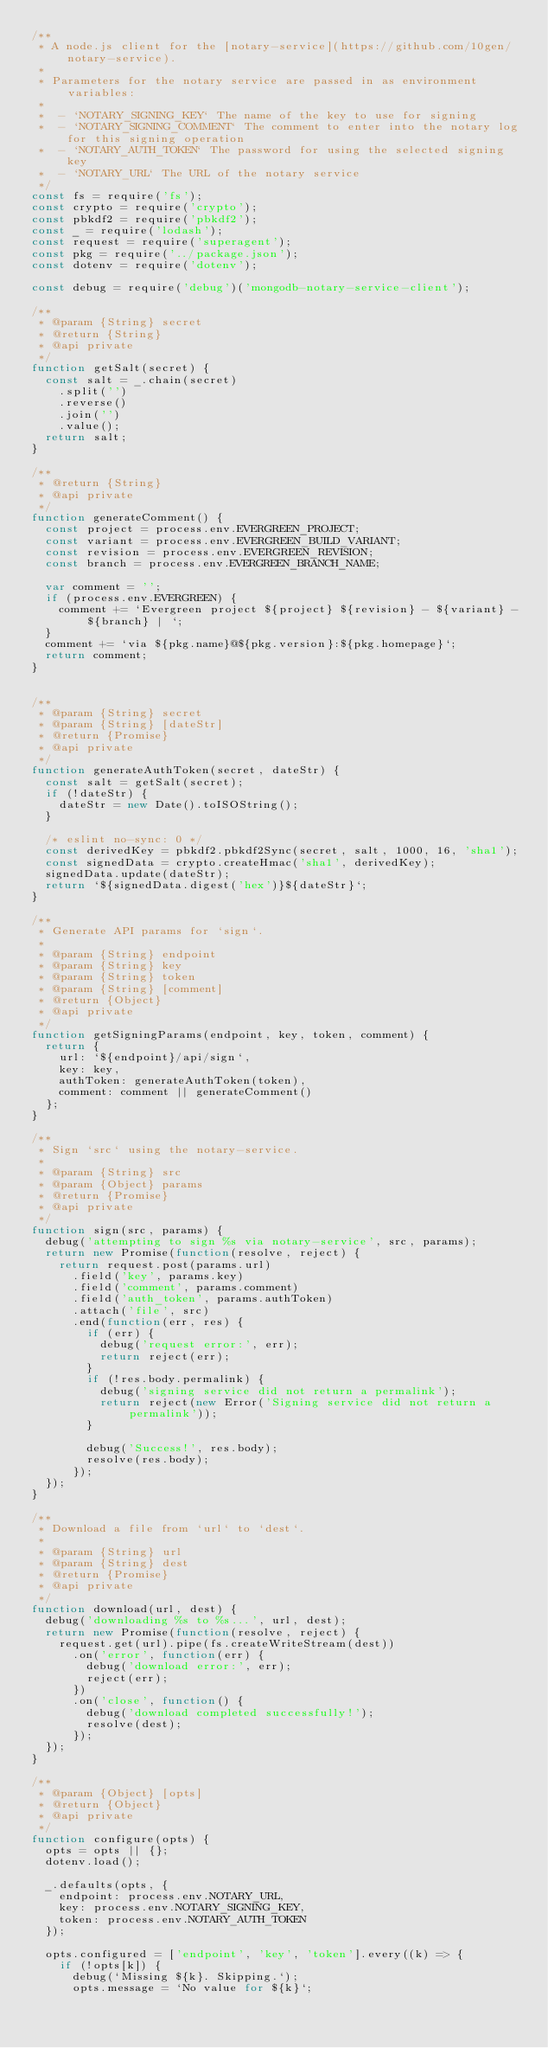Convert code to text. <code><loc_0><loc_0><loc_500><loc_500><_JavaScript_>/**
 * A node.js client for the [notary-service](https://github.com/10gen/notary-service).
 *
 * Parameters for the notary service are passed in as environment variables:
 *
 *  - `NOTARY_SIGNING_KEY` The name of the key to use for signing
 *  - `NOTARY_SIGNING_COMMENT` The comment to enter into the notary log for this signing operation
 *  - `NOTARY_AUTH_TOKEN` The password for using the selected signing key
 *  - `NOTARY_URL` The URL of the notary service
 */
const fs = require('fs');
const crypto = require('crypto');
const pbkdf2 = require('pbkdf2');
const _ = require('lodash');
const request = require('superagent');
const pkg = require('../package.json');
const dotenv = require('dotenv');

const debug = require('debug')('mongodb-notary-service-client');

/**
 * @param {String} secret
 * @return {String}
 * @api private
 */
function getSalt(secret) {
  const salt = _.chain(secret)
    .split('')
    .reverse()
    .join('')
    .value();
  return salt;
}

/**
 * @return {String}
 * @api private
 */
function generateComment() {
  const project = process.env.EVERGREEN_PROJECT;
  const variant = process.env.EVERGREEN_BUILD_VARIANT;
  const revision = process.env.EVERGREEN_REVISION;
  const branch = process.env.EVERGREEN_BRANCH_NAME;

  var comment = '';
  if (process.env.EVERGREEN) {
    comment += `Evergreen project ${project} ${revision} - ${variant} - ${branch} | `;
  }
  comment += `via ${pkg.name}@${pkg.version}:${pkg.homepage}`;
  return comment;
}


/**
 * @param {String} secret
 * @param {String} [dateStr]
 * @return {Promise}
 * @api private
 */
function generateAuthToken(secret, dateStr) {
  const salt = getSalt(secret);
  if (!dateStr) {
    dateStr = new Date().toISOString();
  }

  /* eslint no-sync: 0 */
  const derivedKey = pbkdf2.pbkdf2Sync(secret, salt, 1000, 16, 'sha1');
  const signedData = crypto.createHmac('sha1', derivedKey);
  signedData.update(dateStr);
  return `${signedData.digest('hex')}${dateStr}`;
}

/**
 * Generate API params for `sign`.
 *
 * @param {String} endpoint
 * @param {String} key
 * @param {String} token
 * @param {String} [comment]
 * @return {Object}
 * @api private
 */
function getSigningParams(endpoint, key, token, comment) {
  return {
    url: `${endpoint}/api/sign`,
    key: key,
    authToken: generateAuthToken(token),
    comment: comment || generateComment()
  };
}

/**
 * Sign `src` using the notary-service.
 *
 * @param {String} src
 * @param {Object} params
 * @return {Promise}
 * @api private
 */
function sign(src, params) {
  debug('attempting to sign %s via notary-service', src, params);
  return new Promise(function(resolve, reject) {
    return request.post(params.url)
      .field('key', params.key)
      .field('comment', params.comment)
      .field('auth_token', params.authToken)
      .attach('file', src)
      .end(function(err, res) {
        if (err) {
          debug('request error:', err);
          return reject(err);
        }
        if (!res.body.permalink) {
          debug('signing service did not return a permalink');
          return reject(new Error('Signing service did not return a permalink'));
        }

        debug('Success!', res.body);
        resolve(res.body);
      });
  });
}

/**
 * Download a file from `url` to `dest`.
 *
 * @param {String} url
 * @param {String} dest
 * @return {Promise}
 * @api private
 */
function download(url, dest) {
  debug('downloading %s to %s...', url, dest);
  return new Promise(function(resolve, reject) {
    request.get(url).pipe(fs.createWriteStream(dest))
      .on('error', function(err) {
        debug('download error:', err);
        reject(err);
      })
      .on('close', function() {
        debug('download completed successfully!');
        resolve(dest);
      });
  });
}

/**
 * @param {Object} [opts]
 * @return {Object}
 * @api private
 */
function configure(opts) {
  opts = opts || {};
  dotenv.load();

  _.defaults(opts, {
    endpoint: process.env.NOTARY_URL,
    key: process.env.NOTARY_SIGNING_KEY,
    token: process.env.NOTARY_AUTH_TOKEN
  });

  opts.configured = ['endpoint', 'key', 'token'].every((k) => {
    if (!opts[k]) {
      debug(`Missing ${k}. Skipping.`);
      opts.message = `No value for ${k}`;</code> 